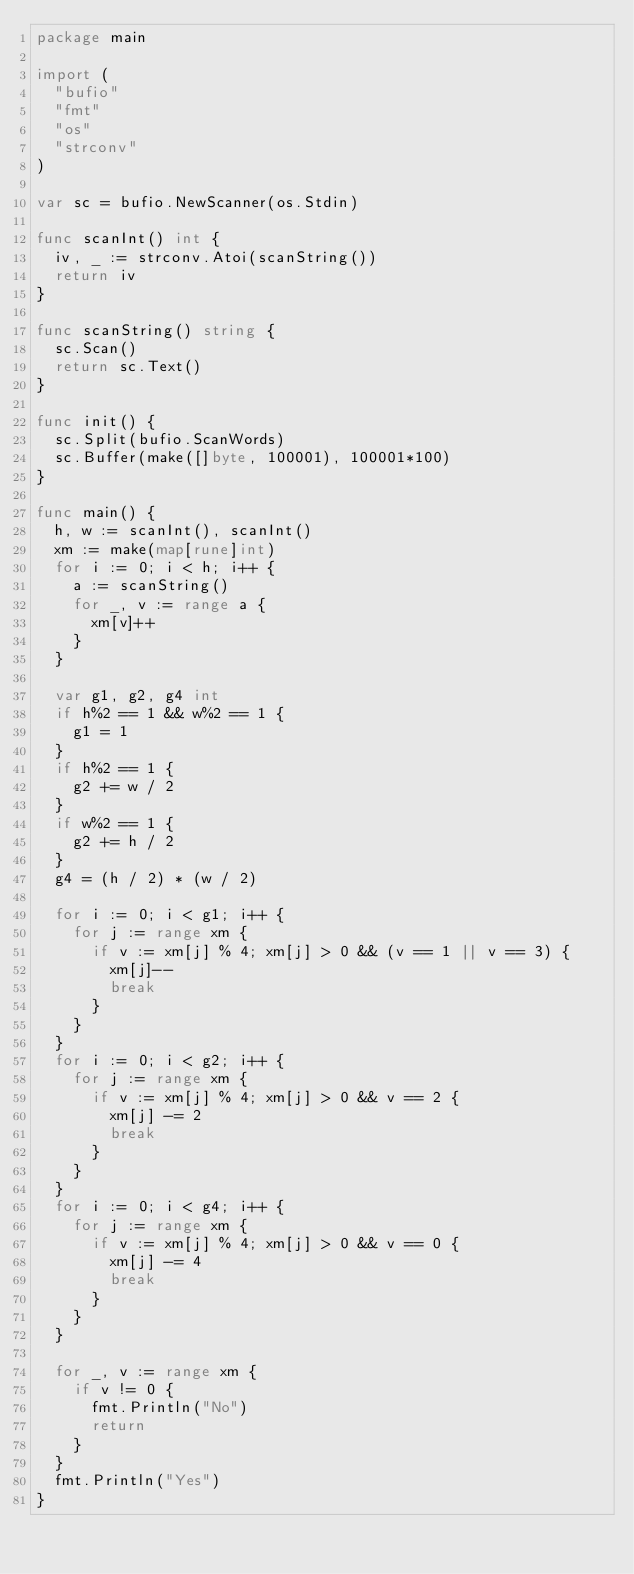Convert code to text. <code><loc_0><loc_0><loc_500><loc_500><_Go_>package main

import (
	"bufio"
	"fmt"
	"os"
	"strconv"
)

var sc = bufio.NewScanner(os.Stdin)

func scanInt() int {
	iv, _ := strconv.Atoi(scanString())
	return iv
}

func scanString() string {
	sc.Scan()
	return sc.Text()
}

func init() {
	sc.Split(bufio.ScanWords)
	sc.Buffer(make([]byte, 100001), 100001*100)
}

func main() {
	h, w := scanInt(), scanInt()
	xm := make(map[rune]int)
	for i := 0; i < h; i++ {
		a := scanString()
		for _, v := range a {
			xm[v]++
		}
	}

	var g1, g2, g4 int
	if h%2 == 1 && w%2 == 1 {
		g1 = 1
	}
	if h%2 == 1 {
		g2 += w / 2
	}
	if w%2 == 1 {
		g2 += h / 2
	}
	g4 = (h / 2) * (w / 2)

	for i := 0; i < g1; i++ {
		for j := range xm {
			if v := xm[j] % 4; xm[j] > 0 && (v == 1 || v == 3) {
				xm[j]--
				break
			}
		}
	}
	for i := 0; i < g2; i++ {
		for j := range xm {
			if v := xm[j] % 4; xm[j] > 0 && v == 2 {
				xm[j] -= 2
				break
			}
		}
	}
	for i := 0; i < g4; i++ {
		for j := range xm {
			if v := xm[j] % 4; xm[j] > 0 && v == 0 {
				xm[j] -= 4
				break
			}
		}
	}

	for _, v := range xm {
		if v != 0 {
			fmt.Println("No")
			return
		}
	}
	fmt.Println("Yes")
}
</code> 